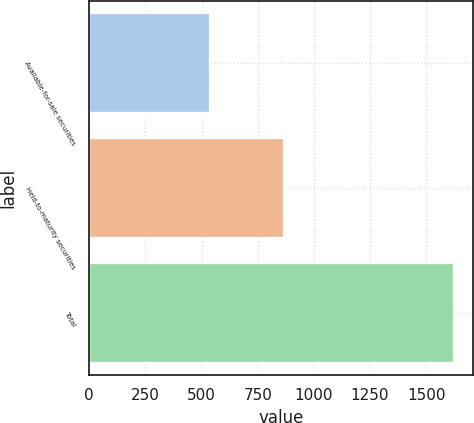<chart> <loc_0><loc_0><loc_500><loc_500><bar_chart><fcel>Available-for-sale securities<fcel>Held-to-maturity securities<fcel>Total<nl><fcel>538<fcel>868<fcel>1625<nl></chart> 